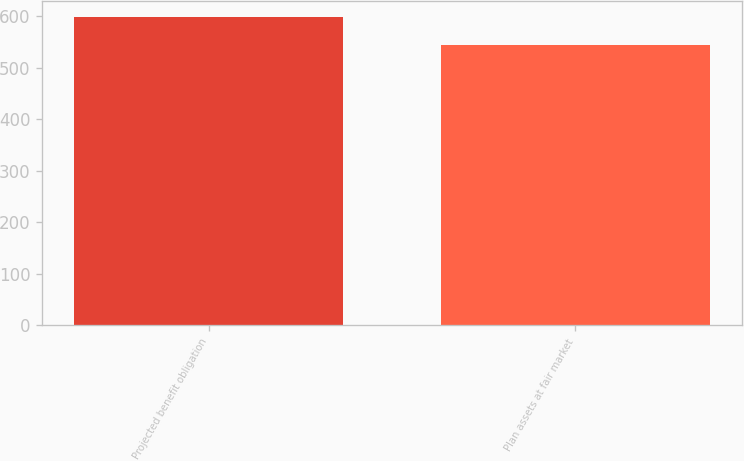Convert chart. <chart><loc_0><loc_0><loc_500><loc_500><bar_chart><fcel>Projected benefit obligation<fcel>Plan assets at fair market<nl><fcel>598.8<fcel>544.2<nl></chart> 